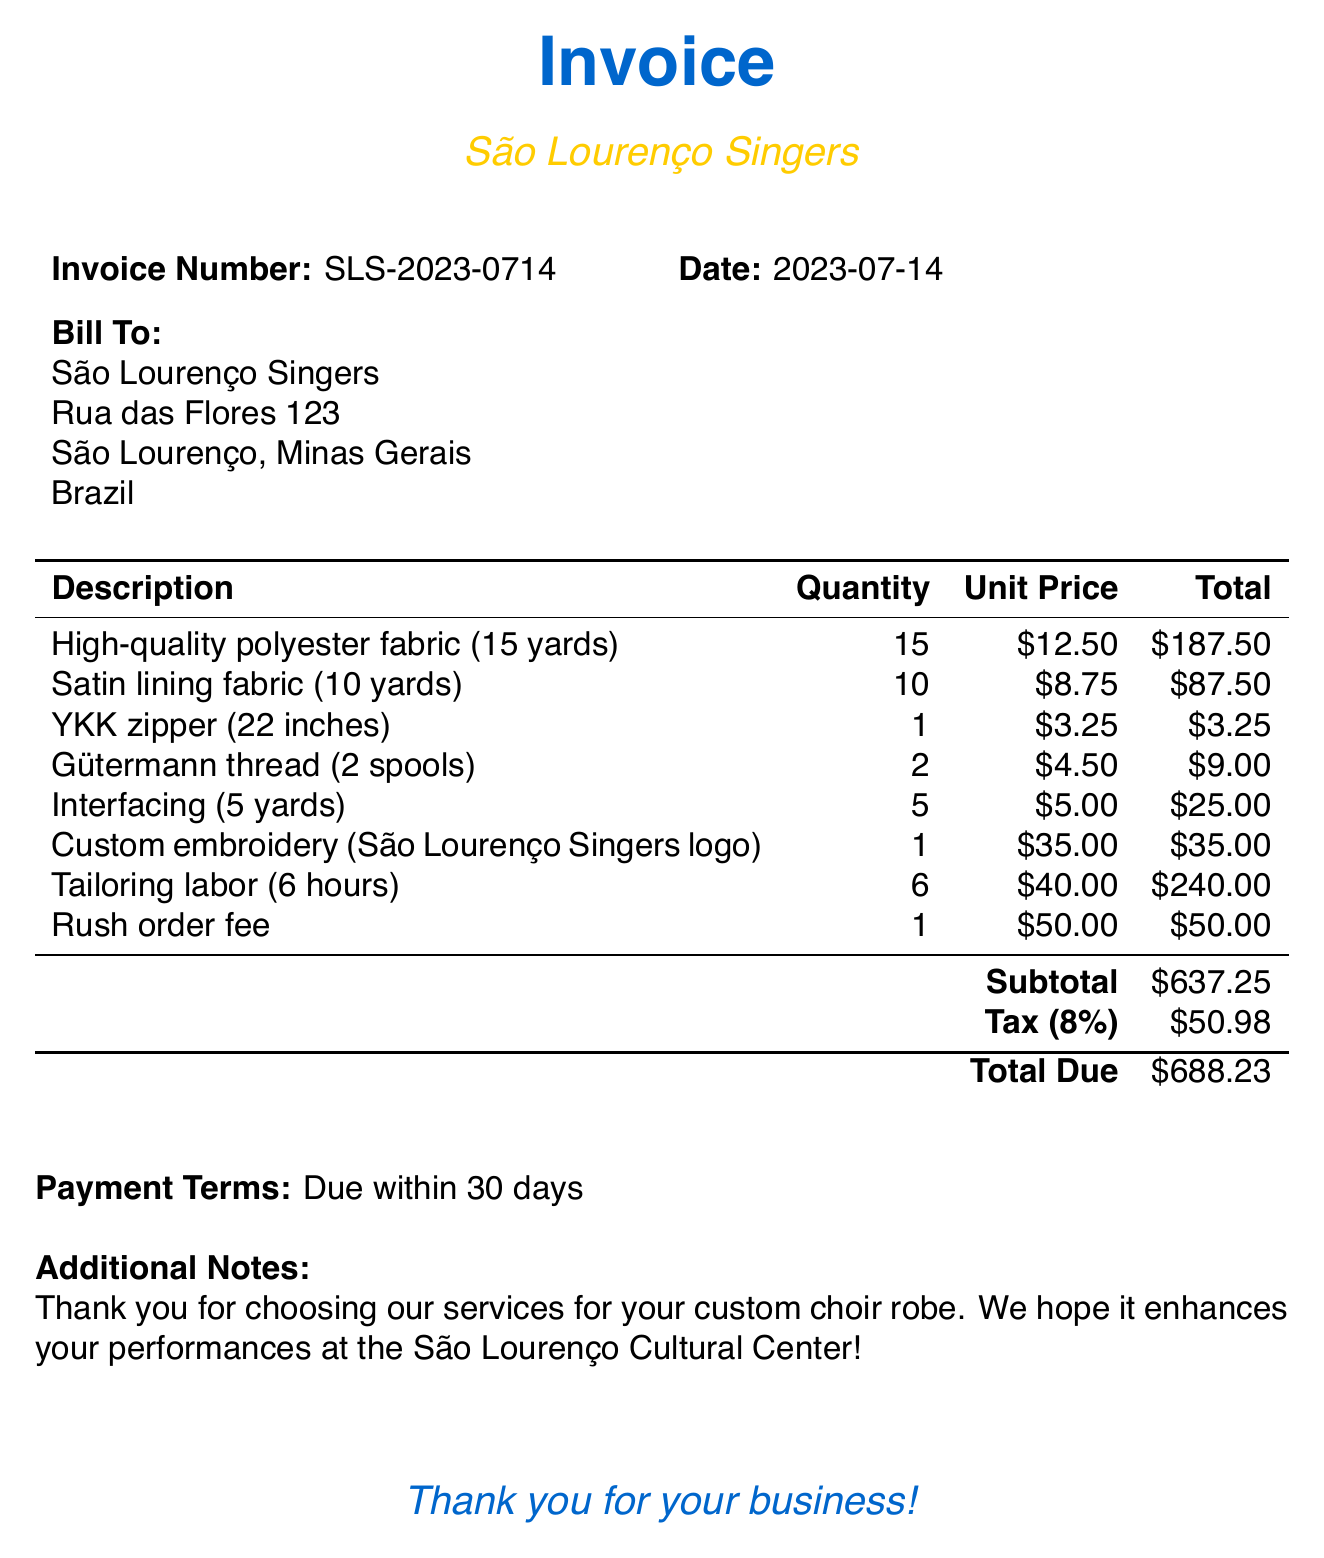What is the invoice number? The invoice number is specifically mentioned in the details section at the top of the document.
Answer: SLS-2023-0714 What is the total amount due? The total amount is calculated at the bottom of the invoice after including the subtotal and tax.
Answer: $688.23 What is the tax rate applied? The tax rate is given in the invoicing details just above the total.
Answer: 8% How many yards of satin lining fabric were ordered? The quantity of satin lining fabric is listed in the itemized section of the document.
Answer: 10 yards How much is the tailoring labor charged per hour? The unit price for tailoring labor is specified in the itemized charges section.
Answer: $40.00 What is the total cost for the high-quality polyester fabric? The total for high-quality polyester fabric combines the unit price and quantity.
Answer: $187.50 What additional fee was charged for urgency? The rush order fee is explicitly detailed in the itemized list.
Answer: $50.00 What is the payment term stated in the document? The payment terms are clearly outlined in the invoice details section.
Answer: Due within 30 days What type of service does this invoice pertain to? The invoice mentions the specific service related to the items listed.
Answer: Custom choir robe 